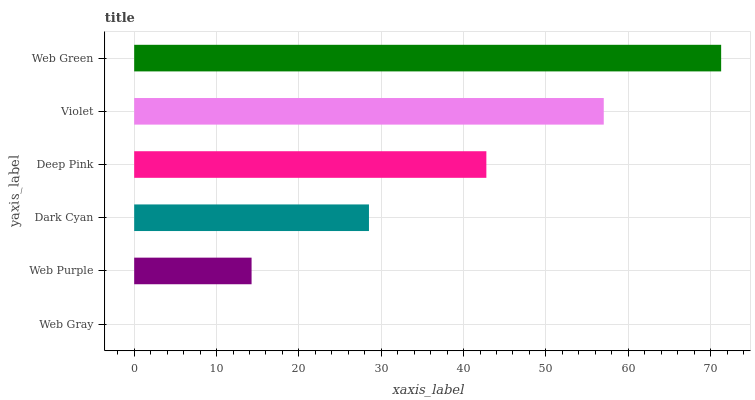Is Web Gray the minimum?
Answer yes or no. Yes. Is Web Green the maximum?
Answer yes or no. Yes. Is Web Purple the minimum?
Answer yes or no. No. Is Web Purple the maximum?
Answer yes or no. No. Is Web Purple greater than Web Gray?
Answer yes or no. Yes. Is Web Gray less than Web Purple?
Answer yes or no. Yes. Is Web Gray greater than Web Purple?
Answer yes or no. No. Is Web Purple less than Web Gray?
Answer yes or no. No. Is Deep Pink the high median?
Answer yes or no. Yes. Is Dark Cyan the low median?
Answer yes or no. Yes. Is Web Gray the high median?
Answer yes or no. No. Is Web Gray the low median?
Answer yes or no. No. 